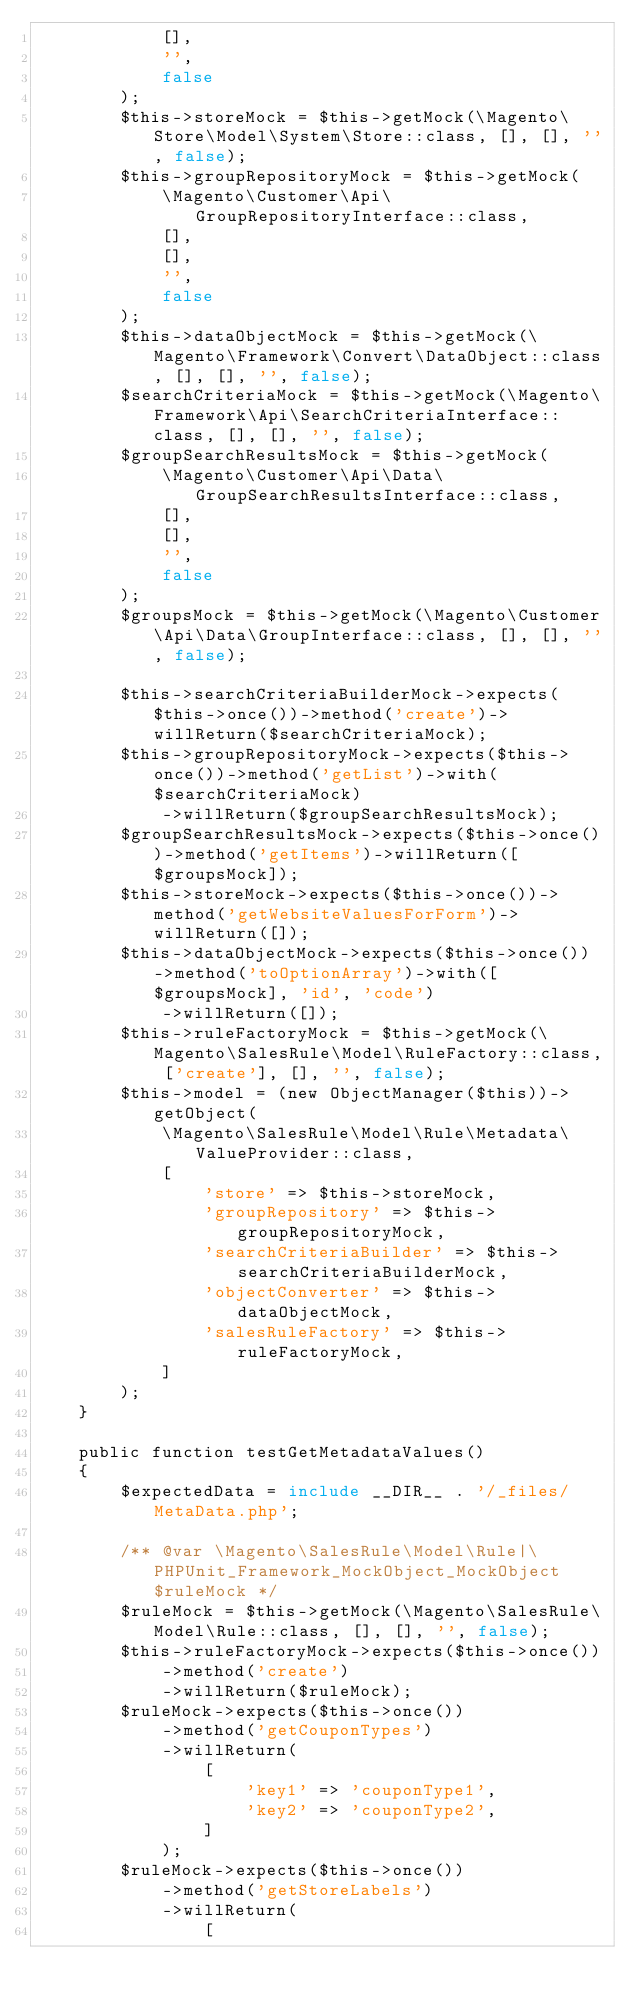Convert code to text. <code><loc_0><loc_0><loc_500><loc_500><_PHP_>            [],
            '',
            false
        );
        $this->storeMock = $this->getMock(\Magento\Store\Model\System\Store::class, [], [], '', false);
        $this->groupRepositoryMock = $this->getMock(
            \Magento\Customer\Api\GroupRepositoryInterface::class,
            [],
            [],
            '',
            false
        );
        $this->dataObjectMock = $this->getMock(\Magento\Framework\Convert\DataObject::class, [], [], '', false);
        $searchCriteriaMock = $this->getMock(\Magento\Framework\Api\SearchCriteriaInterface::class, [], [], '', false);
        $groupSearchResultsMock = $this->getMock(
            \Magento\Customer\Api\Data\GroupSearchResultsInterface::class,
            [],
            [],
            '',
            false
        );
        $groupsMock = $this->getMock(\Magento\Customer\Api\Data\GroupInterface::class, [], [], '', false);

        $this->searchCriteriaBuilderMock->expects($this->once())->method('create')->willReturn($searchCriteriaMock);
        $this->groupRepositoryMock->expects($this->once())->method('getList')->with($searchCriteriaMock)
            ->willReturn($groupSearchResultsMock);
        $groupSearchResultsMock->expects($this->once())->method('getItems')->willReturn([$groupsMock]);
        $this->storeMock->expects($this->once())->method('getWebsiteValuesForForm')->willReturn([]);
        $this->dataObjectMock->expects($this->once())->method('toOptionArray')->with([$groupsMock], 'id', 'code')
            ->willReturn([]);
        $this->ruleFactoryMock = $this->getMock(\Magento\SalesRule\Model\RuleFactory::class, ['create'], [], '', false);
        $this->model = (new ObjectManager($this))->getObject(
            \Magento\SalesRule\Model\Rule\Metadata\ValueProvider::class,
            [
                'store' => $this->storeMock,
                'groupRepository' => $this->groupRepositoryMock,
                'searchCriteriaBuilder' => $this->searchCriteriaBuilderMock,
                'objectConverter' => $this->dataObjectMock,
                'salesRuleFactory' => $this->ruleFactoryMock,
            ]
        );
    }

    public function testGetMetadataValues()
    {
        $expectedData = include __DIR__ . '/_files/MetaData.php';

        /** @var \Magento\SalesRule\Model\Rule|\PHPUnit_Framework_MockObject_MockObject $ruleMock */
        $ruleMock = $this->getMock(\Magento\SalesRule\Model\Rule::class, [], [], '', false);
        $this->ruleFactoryMock->expects($this->once())
            ->method('create')
            ->willReturn($ruleMock);
        $ruleMock->expects($this->once())
            ->method('getCouponTypes')
            ->willReturn(
                [
                    'key1' => 'couponType1',
                    'key2' => 'couponType2',
                ]
            );
        $ruleMock->expects($this->once())
            ->method('getStoreLabels')
            ->willReturn(
                [</code> 